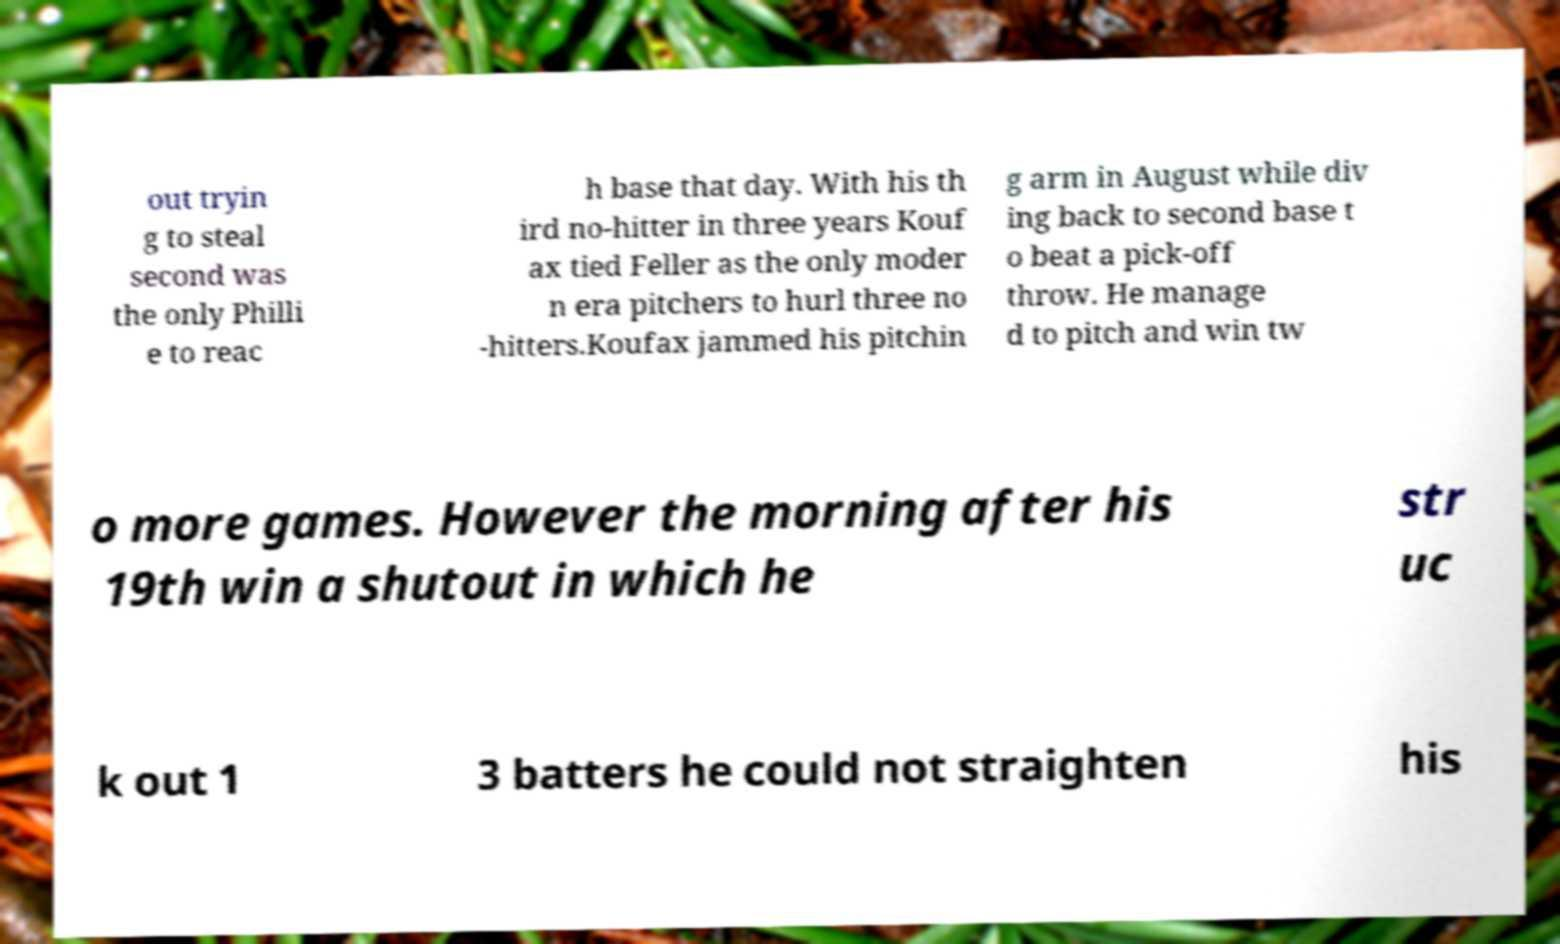Can you read and provide the text displayed in the image?This photo seems to have some interesting text. Can you extract and type it out for me? out tryin g to steal second was the only Philli e to reac h base that day. With his th ird no-hitter in three years Kouf ax tied Feller as the only moder n era pitchers to hurl three no -hitters.Koufax jammed his pitchin g arm in August while div ing back to second base t o beat a pick-off throw. He manage d to pitch and win tw o more games. However the morning after his 19th win a shutout in which he str uc k out 1 3 batters he could not straighten his 